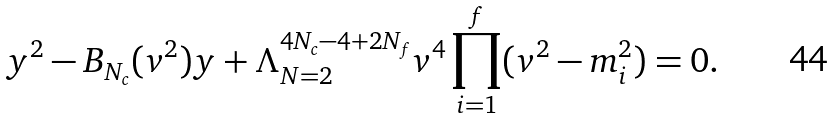Convert formula to latex. <formula><loc_0><loc_0><loc_500><loc_500>y ^ { 2 } - B _ { N _ { c } } ( v ^ { 2 } ) y + \Lambda ^ { 4 N _ { c } - 4 + 2 N _ { f } } _ { N = 2 } v ^ { 4 } \prod _ { i = 1 } ^ { f } ( v ^ { 2 } - m _ { i } ^ { 2 } ) = 0 .</formula> 